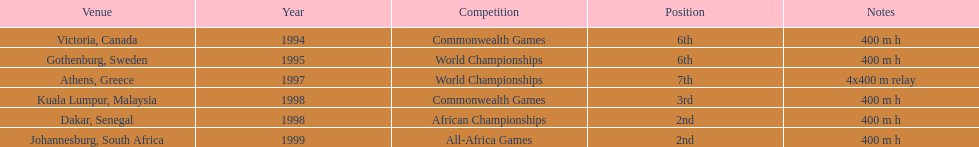Where was the next venue after athens, greece? Kuala Lumpur, Malaysia. 